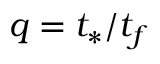<formula> <loc_0><loc_0><loc_500><loc_500>q = t _ { * } / t _ { f }</formula> 